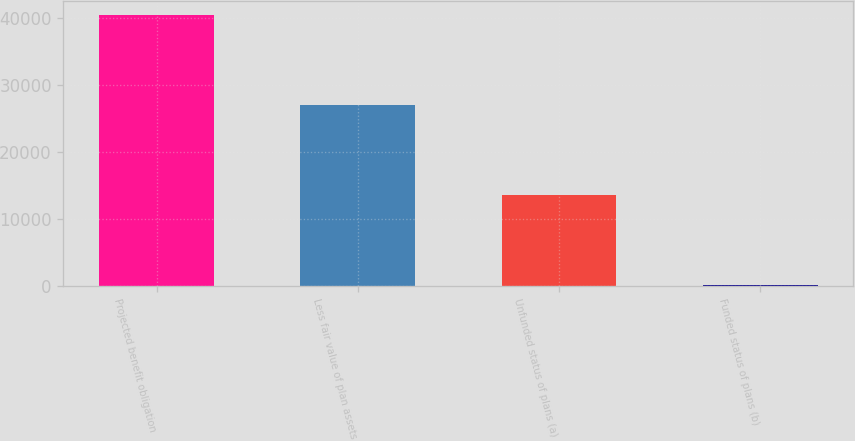Convert chart. <chart><loc_0><loc_0><loc_500><loc_500><bar_chart><fcel>Projected benefit obligation<fcel>Less fair value of plan assets<fcel>Unfunded status of plans (a)<fcel>Funded status of plans (b)<nl><fcel>40478<fcel>26976<fcel>13502<fcel>178<nl></chart> 